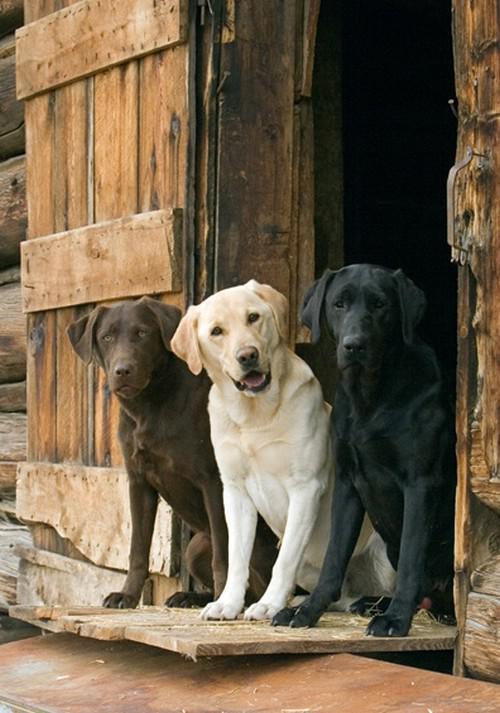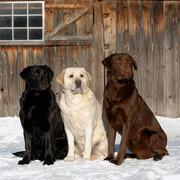The first image is the image on the left, the second image is the image on the right. Examine the images to the left and right. Is the description "An image shows three different solid color dogs posed side-by-side, with the black dog in the middle." accurate? Answer yes or no. No. The first image is the image on the left, the second image is the image on the right. Analyze the images presented: Is the assertion "The right image contains three dogs seated outside." valid? Answer yes or no. Yes. 